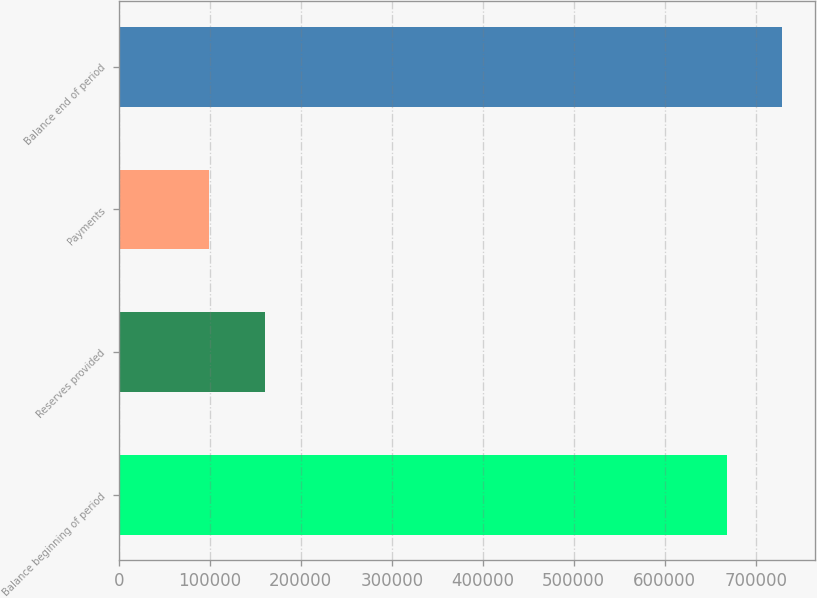Convert chart to OTSL. <chart><loc_0><loc_0><loc_500><loc_500><bar_chart><fcel>Balance beginning of period<fcel>Reserves provided<fcel>Payments<fcel>Balance end of period<nl><fcel>668100<fcel>160705<fcel>99645<fcel>729160<nl></chart> 